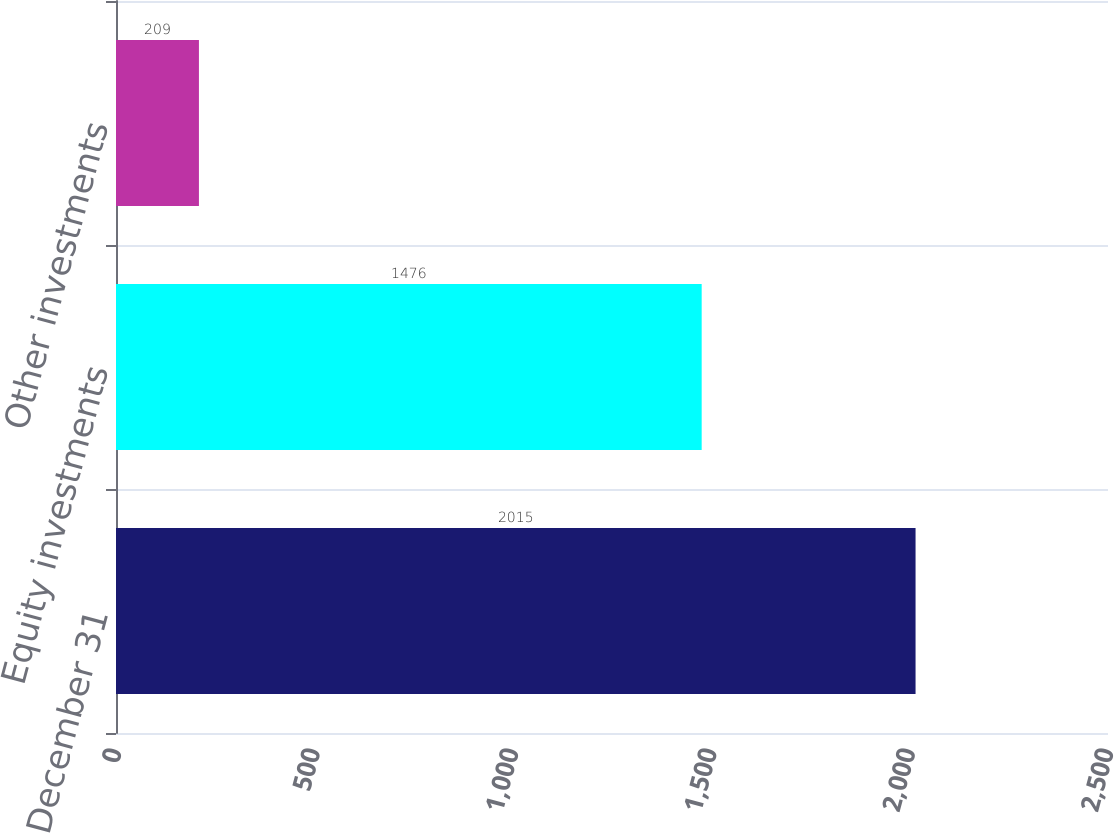Convert chart to OTSL. <chart><loc_0><loc_0><loc_500><loc_500><bar_chart><fcel>December 31<fcel>Equity investments<fcel>Other investments<nl><fcel>2015<fcel>1476<fcel>209<nl></chart> 